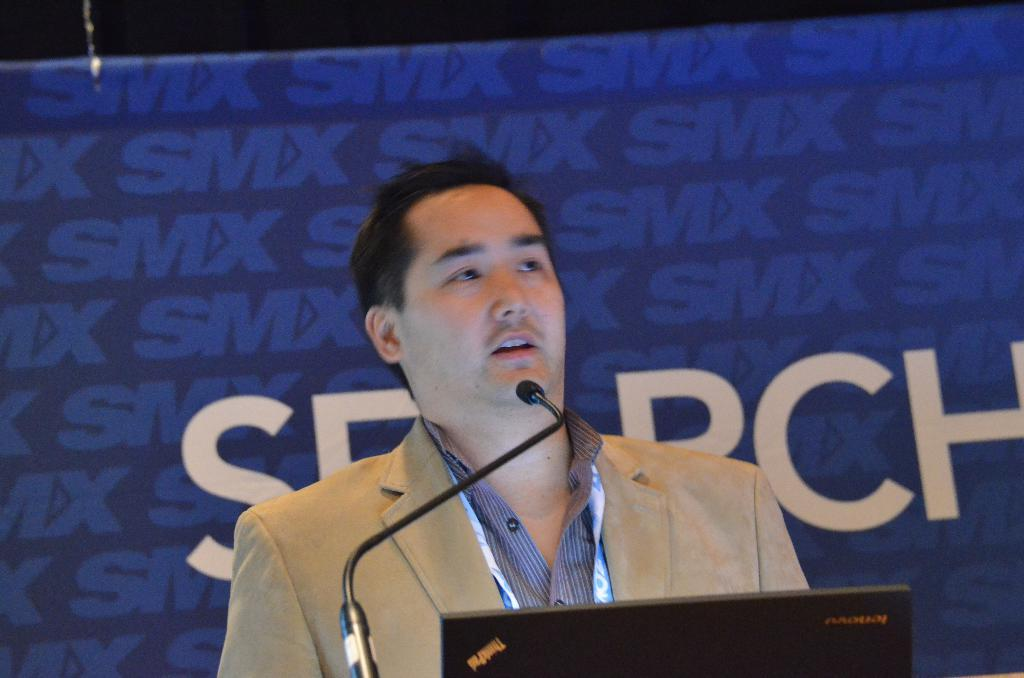What is the main subject in the foreground of the image? There is a person in the foreground of the image. What is the person doing in the image? The person is in front of a microphone. What can be seen in the background of the image? There is a wall and a poster in the background of the image. Where might this image have been taken? The image may have been taken in a hall. What type of mitten is the person wearing in the image? There is no mitten visible in the image; the person is in front of a microphone, and no mittens are mentioned in the provided facts. 